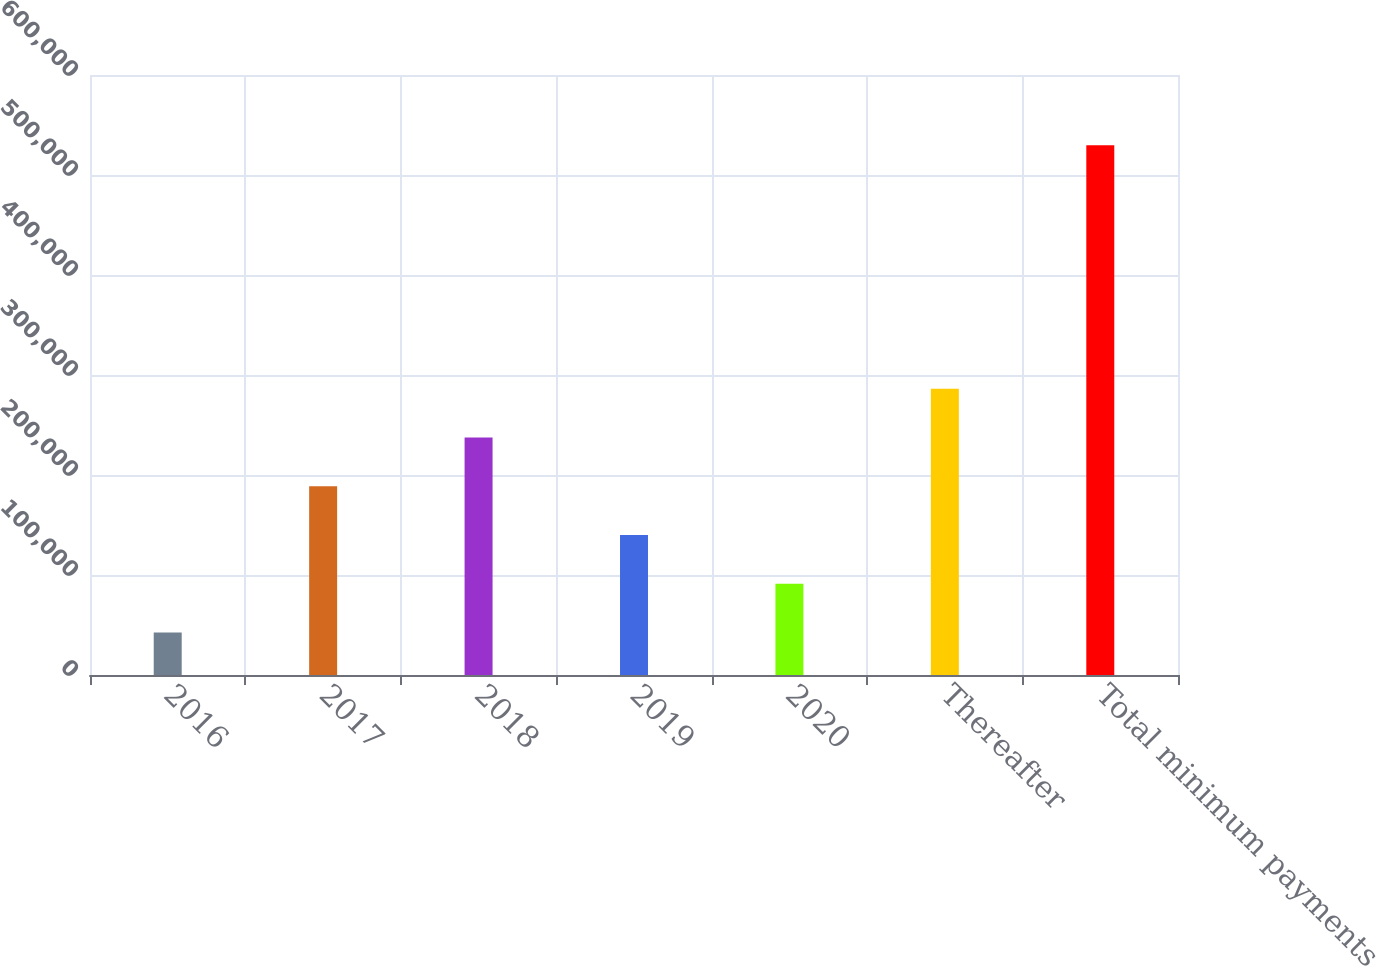Convert chart. <chart><loc_0><loc_0><loc_500><loc_500><bar_chart><fcel>2016<fcel>2017<fcel>2018<fcel>2019<fcel>2020<fcel>Thereafter<fcel>Total minimum payments<nl><fcel>42545<fcel>188705<fcel>237425<fcel>139985<fcel>91264.9<fcel>286144<fcel>529744<nl></chart> 